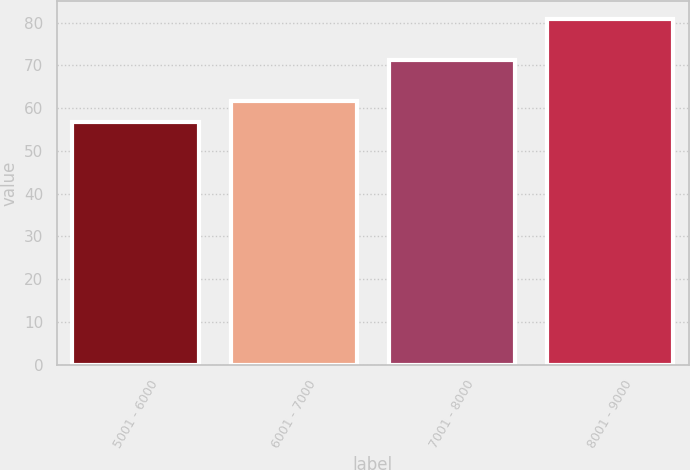<chart> <loc_0><loc_0><loc_500><loc_500><bar_chart><fcel>5001 - 6000<fcel>6001 - 7000<fcel>7001 - 8000<fcel>8001 - 9000<nl><fcel>56.68<fcel>61.58<fcel>71.22<fcel>80.92<nl></chart> 